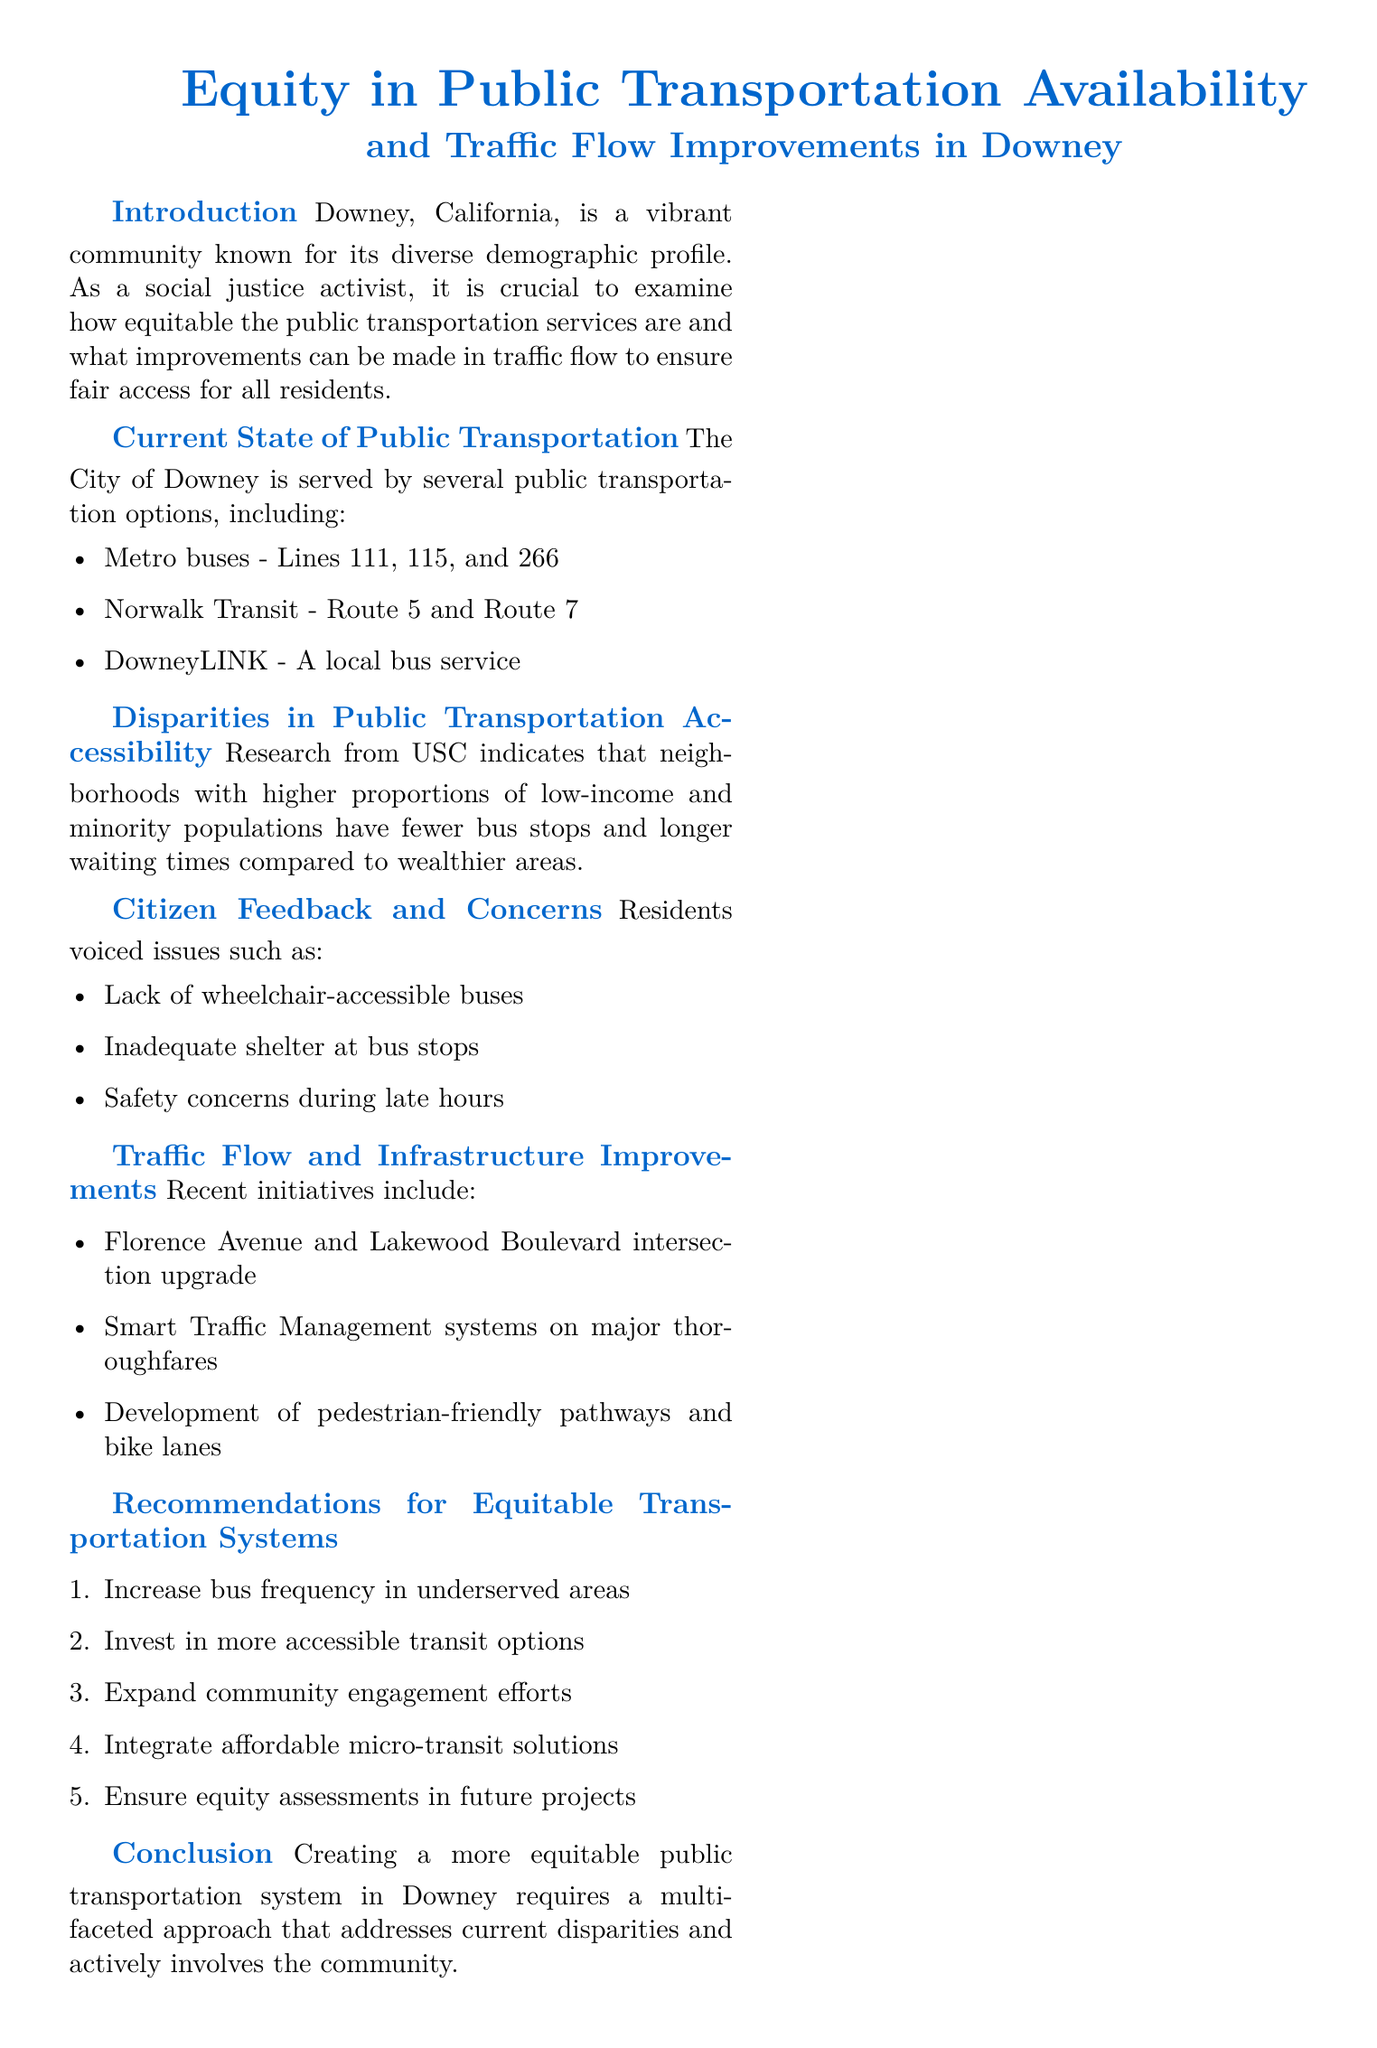What are the Metro bus lines serving Downey? The document lists the Metro bus lines as 111, 115, and 266.
Answer: Lines 111, 115, and 266 What issues did residents voice regarding public transportation? The document mentions issues like lack of wheelchair-accessible buses, inadequate shelter at bus stops, and safety concerns during late hours.
Answer: Lack of wheelchair-accessible buses What intersection was upgraded as part of traffic flow improvements? The document states that the Florence Avenue and Lakewood Boulevard intersection was upgraded.
Answer: Florence Avenue and Lakewood Boulevard What is one of the recommendations for equitable transportation systems? The document lists increasing bus frequency in underserved areas as one recommendation.
Answer: Increase bus frequency Which organization conducted research on transportation inequities? The document cites USC as the organization conducting the research.
Answer: USC How many public transportation options are mentioned in the document? The document mentions three main types of public transportation options available in Downey.
Answer: Three What aspect of community needs does the report emphasize? The report emphasizes community engagement efforts as crucial for addressing transportation equity.
Answer: Community engagement efforts What do the recent initiatives include regarding traffic management? The document notes the implementation of Smart Traffic Management systems on major thoroughfares.
Answer: Smart Traffic Management systems 